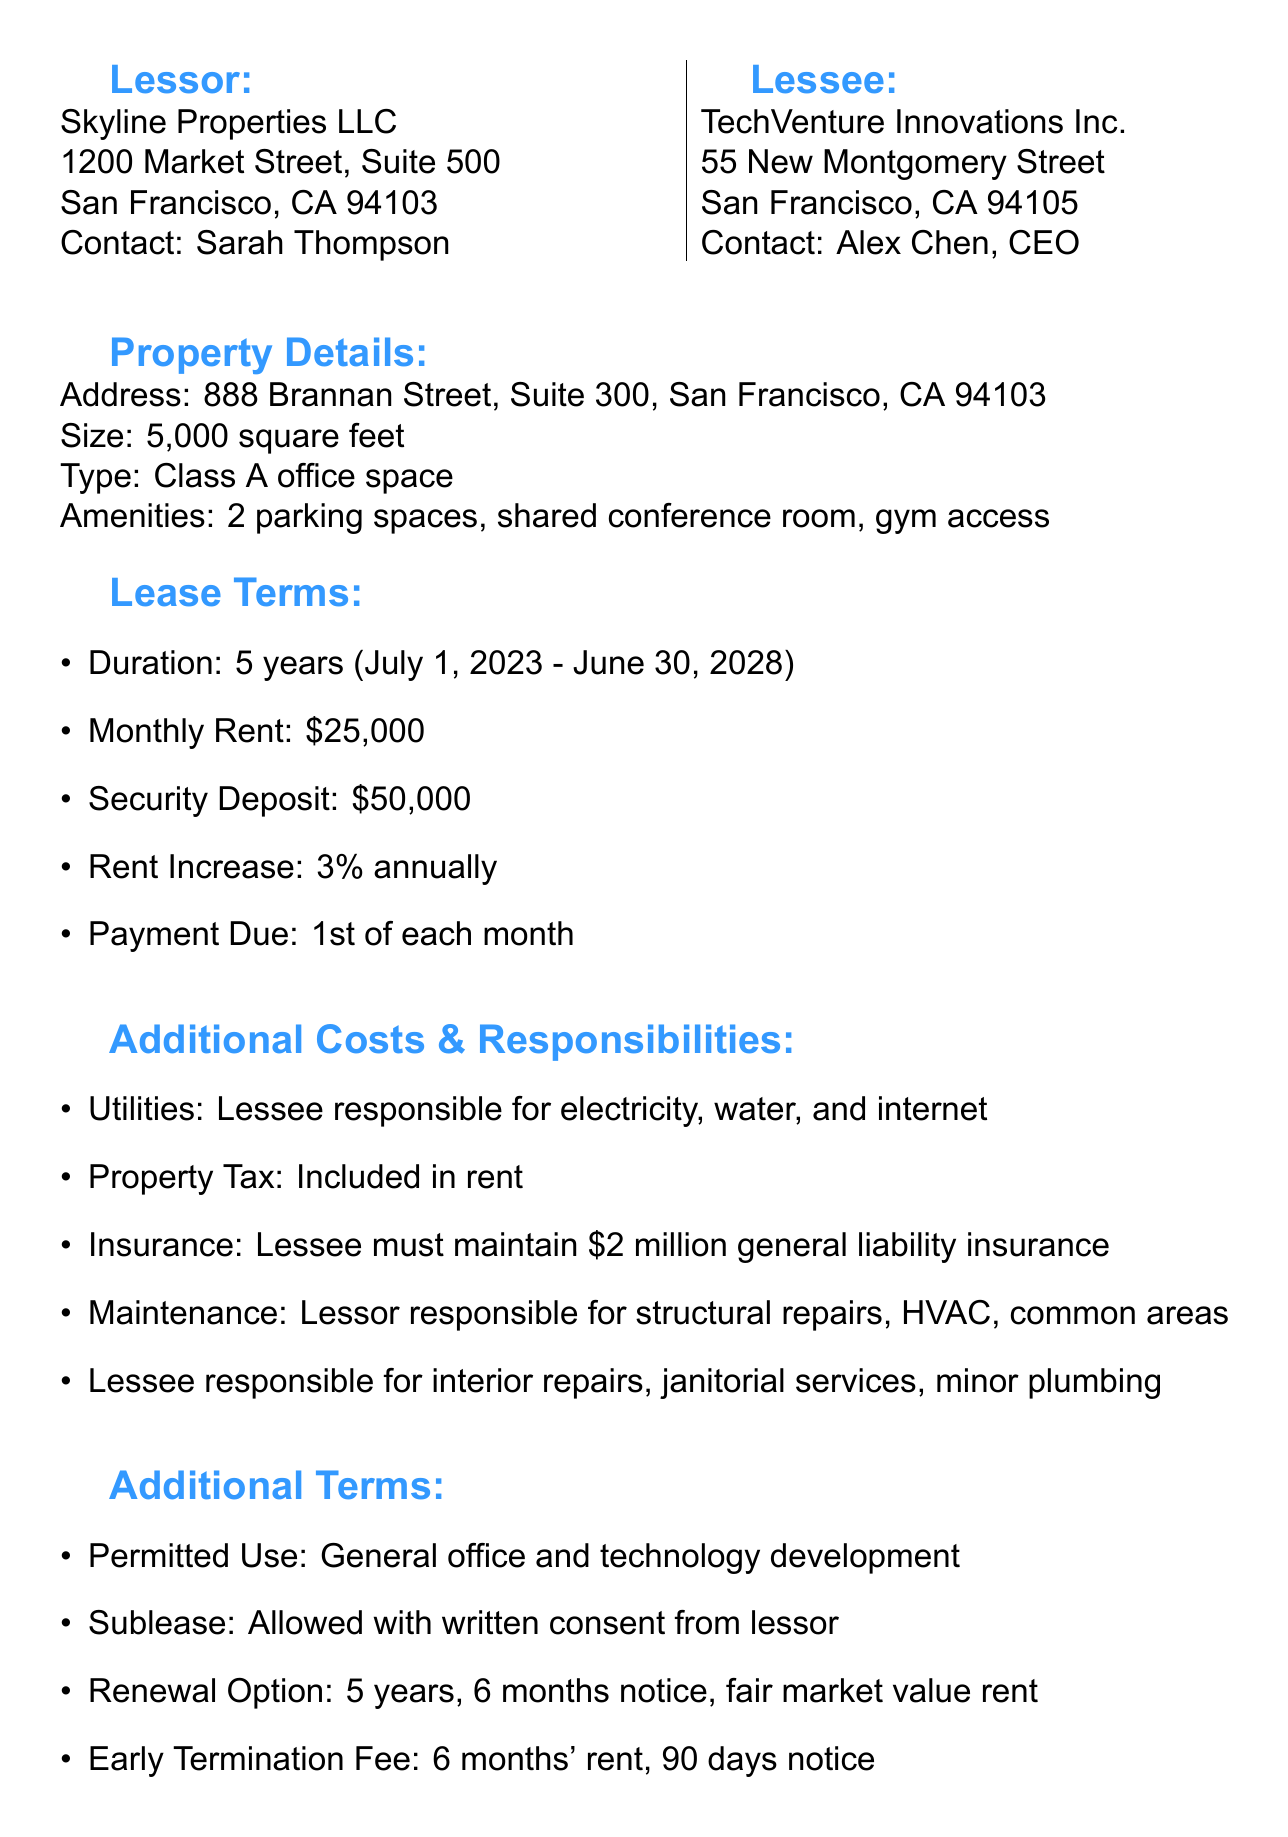What is the monthly rent? The monthly rent is stated in the lease terms section and is \$25,000.
Answer: $25,000 Who is the property manager? The contact person for the lessor is mentioned, which is Sarah Thompson.
Answer: Sarah Thompson What is the total duration of the lease? The lease duration is specified and is 5 years, from July 1, 2023 to June 30, 2028.
Answer: 5 years What is the required security deposit? The security deposit amount is given in the lease terms and is \$50,000.
Answer: $50,000 What is the allowed use of the property? The permitted use section specifies that it can be used for general office and technology development.
Answer: General office and technology development What happens if the lessee wants to terminate the lease early? The termination clause indicates an early termination fee and notice requirement, specifically mentioning a fee of 6 months' rent and a 90-day notice.
Answer: 6 months' rent How much is the tenant improvement allowance? The special provisions section mentions the tenant improvement allowance as \$50 per square foot.
Answer: $50 per square foot Are utilities included in the rent? The additional costs section states that the lessee is responsible for electricity, water, and internet, indicating they are not included.
Answer: No Can the lessee sublease the property? The document states that subleasing is allowed with written consent from the lessor.
Answer: Yes, with written consent What is the rent increase percentage per year? The lease terms section specifies that rent will increase by 3% annually.
Answer: 3% annually 